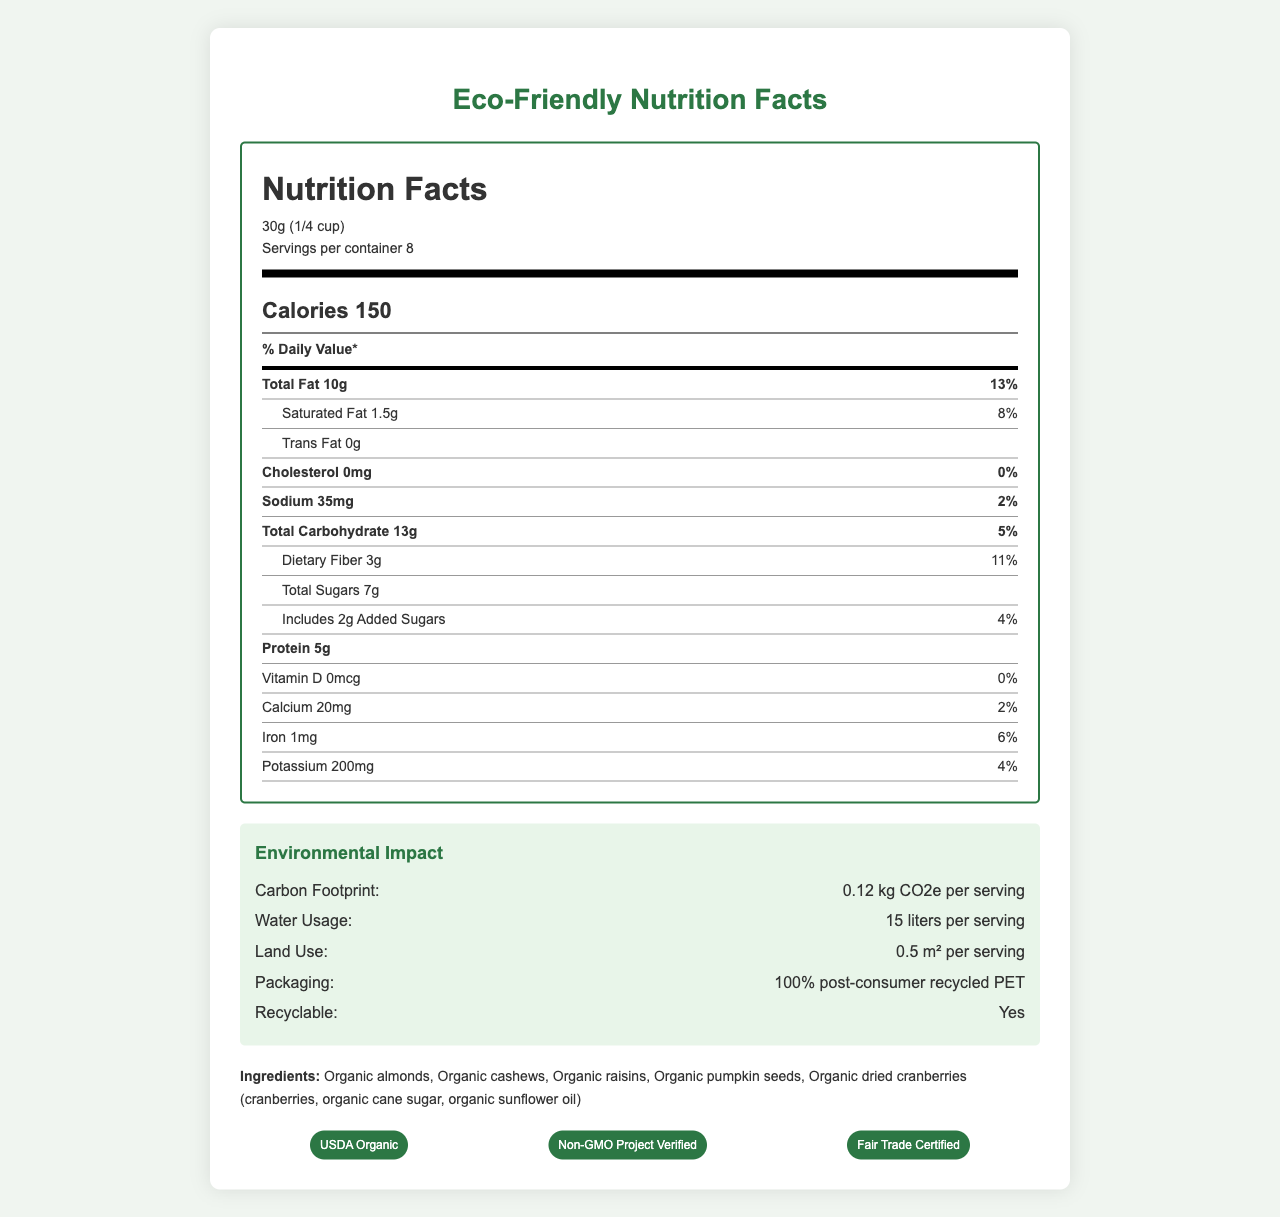what is the serving size? The serving size is listed at the top of the Nutrition Facts section as 30g (1/4 cup).
Answer: 30g (1/4 cup) how many calories are in one serving? The calorie content per serving is boldly displayed just below the serving size information, indicating 150 calories.
Answer: 150 what is the total fat content in one serving? The total fat content is listed as 10g in the nutrition label under the nutrient information.
Answer: 10g how much dietary fiber does one serving contain? The dietary fiber content is listed under the total carbohydrate information in the nutrition label, which is 3g per serving.
Answer: 3g what is the carbon footprint per serving of the EcoNut Organic Trail Mix? The carbon footprint per serving is presented in the Environmental Impact section as 0.12 kg CO2e.
Answer: 0.12 kg CO2e what percentage of the daily value for saturated fat does one serving provide? The nutrition label lists 1.5g of saturated fat per serving, which corresponds to 8% of the daily value.
Answer: 8% how is the packaging described in terms of recyclability? The packaging recyclability section describes the material as 100% post-consumer recycled PET, confirms it is recyclable, and includes instructions to rinse and place it in the recycling bin.
Answer: 100% post-consumer recycled PET, recyclable, rinse and place in recycling bin which certifications does the EcoNut Organic Trail Mix have? A. USDA Organic, B. Non-GMO Project Verified, C. Fair Trade Certified, D. All of the above The certifications section lists USDA Organic, Non-GMO Project Verified, and Fair Trade Certified, hence all of the above.
Answer: D. All of the above what is not biodegradable in this product? The section on packaging recyclability explicitly states that the packaging is "not biodegradable".
Answer: The packaging does the product contain any allergens? The allergens section notes that the product contains tree nuts (almonds, cashews).
Answer: Yes summarize the environmental impact aspect of the EcoNut Organic Trail Mix. The environmental impact section provides detailed data on the carbon footprint breakdown, water usage, land use, and packaging material, recyclability, and biodegradability status.
Answer: The EcoNut Organic Trail Mix has a carbon footprint of 0.12 kg CO2e per serving, with 0.08 kg CO2e from production, 0.02 kg CO2e from packaging, and 0.02 kg CO2e from transportation. Additionally, each serving uses 15 liters of water and 0.5 m² of land. Its packaging is made from 100% post-consumer recycled PET, is recyclable, but not biodegradable. where are the cashews sourced from? The sourcing section specifies that the cashews are sourced from Vietnam.
Answer: Vietnam what is the total water usage per container of the EcoNut Organic Trail Mix? The document provides water usage per serving, but does not explicitly describe the total water usage per container.
Answer: Not enough information how long is the shelf life of EcoNut Organic Trail Mix from the production date? The shelf life is explicitly mentioned as 12 months from the production date in the product details.
Answer: 12 months what quantities of Vitamin D and Trans Fat are present in one serving? A. 0mcg of Vitamin D, 1g of Trans Fat, B. 1mcg of Vitamin D, 0g of Trans Fat, C. 0mcg of Vitamin D, 0g of Trans Fat, D. 0g of Vitamin D, 0.5g of Trans Fat The nutrition label indicates there is 0mcg of Vitamin D and 0g of Trans Fat in one serving.
Answer: C. 0mcg of Vitamin D, 0g of Trans Fat does the product include any added sugars? The nutrition label section on sugars clearly states that there are 2g of added sugars per serving.
Answer: Yes 